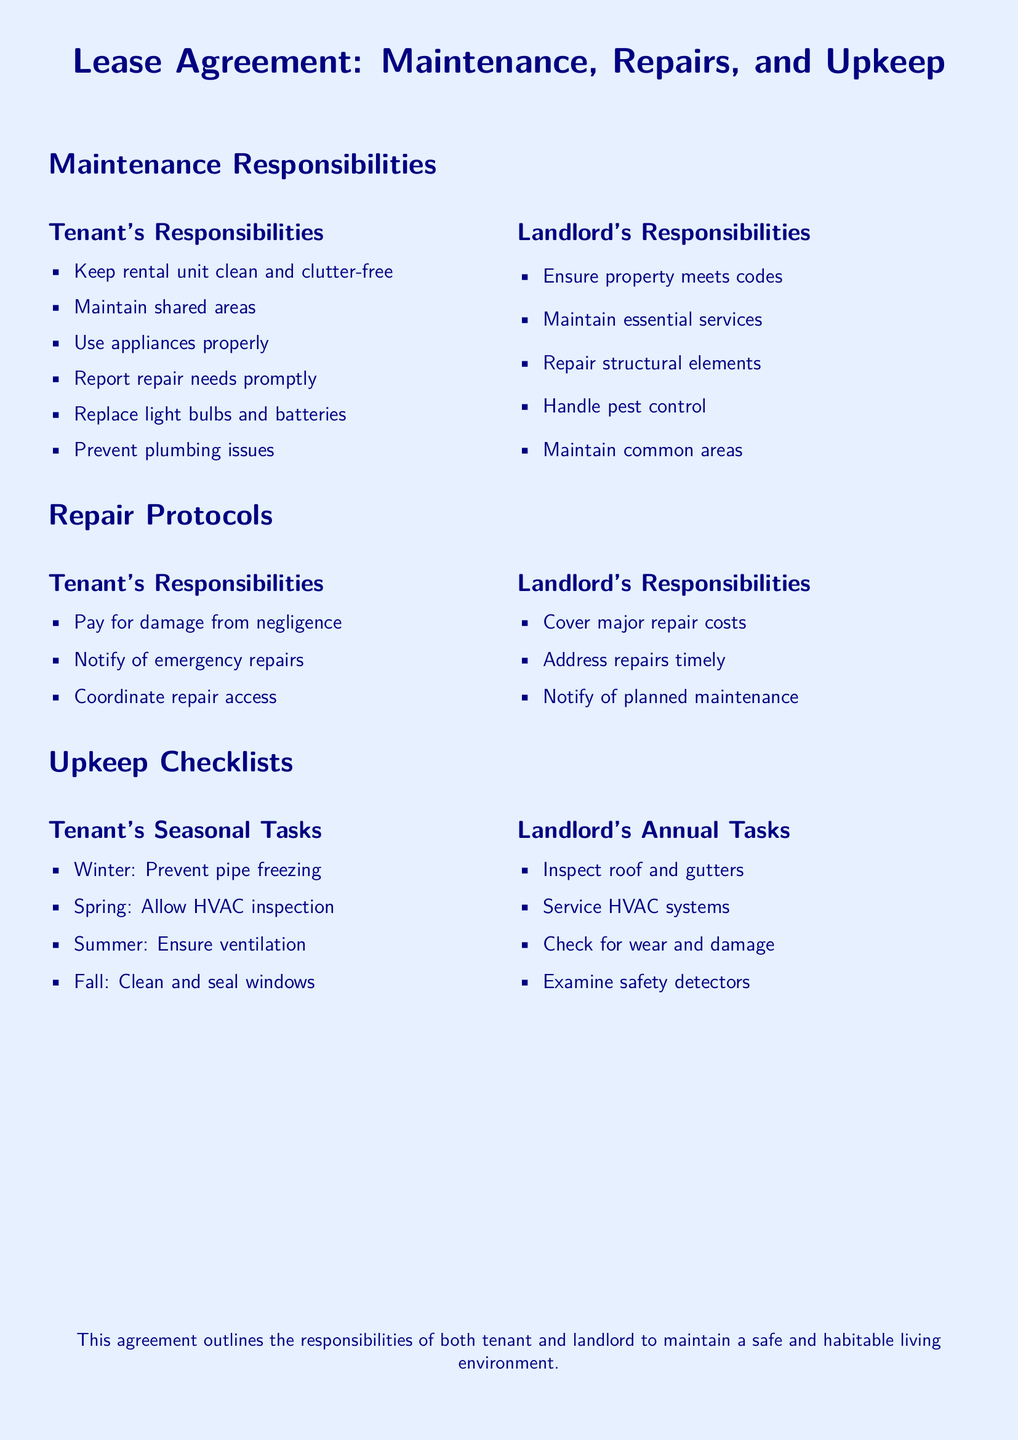What are tenants responsible for regarding cleanliness? Tenants are responsible for keeping the rental unit clean and clutter-free.
Answer: Keeping rental unit clean and clutter-free What is one of the landlord's responsibilities? One of the landlord's responsibilities is to maintain essential services.
Answer: Maintain essential services What should tenants do to plumbing issues? Tenants should prevent plumbing issues.
Answer: Prevent plumbing issues What is required from tenants during emergency repairs? Tenants are required to notify of emergency repairs.
Answer: Notify of emergency repairs How often should the landlord inspect the roof and gutters? The landlord should inspect the roof and gutters annually.
Answer: Annually What seasonal task should tenants do in winter? Tenants should prevent pipe freezing.
Answer: Prevent pipe freezing What should landlords do regarding planned maintenance? Landlords should notify of planned maintenance.
Answer: Notify of planned maintenance Who pays for damage caused by negligence? Tenants pay for damage from negligence.
Answer: Pay for damage from negligence 